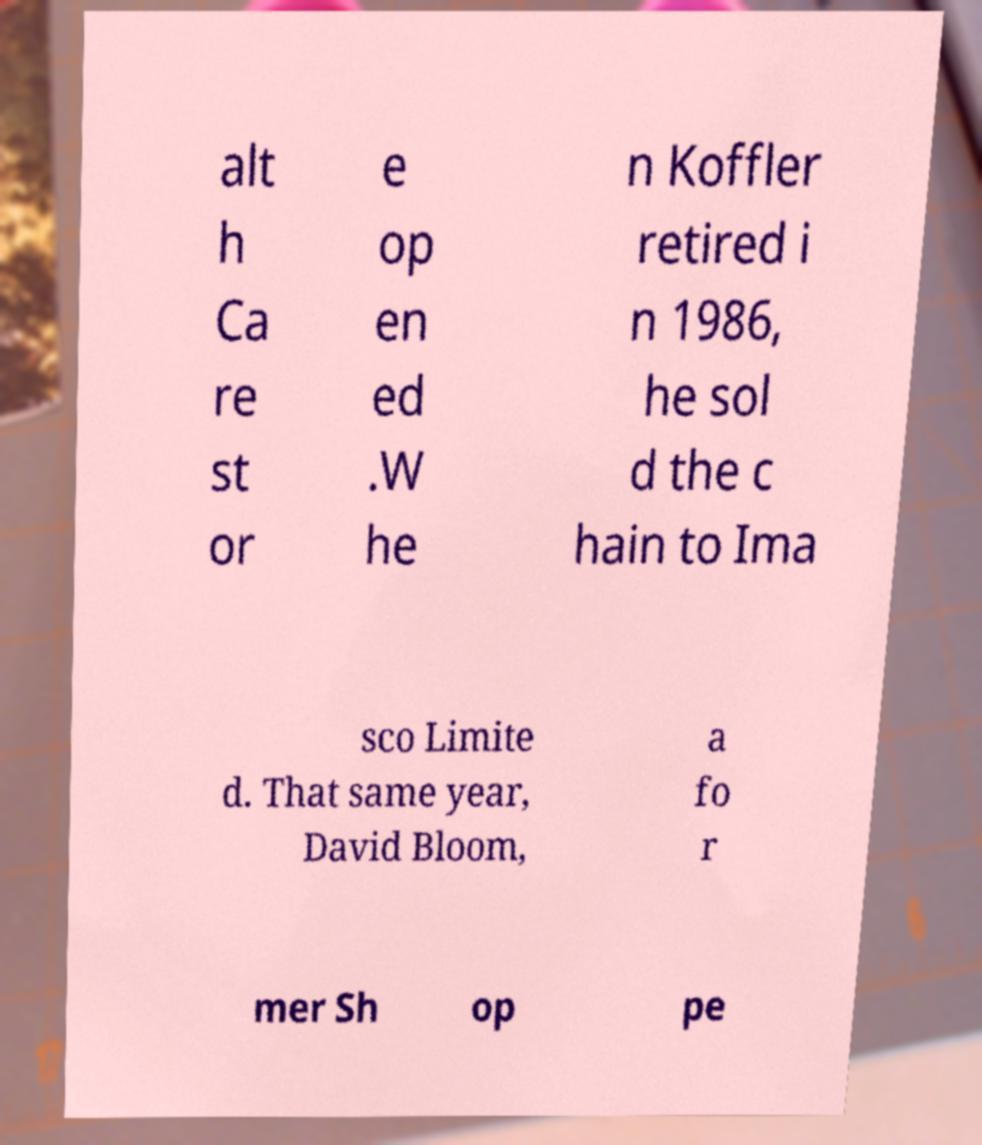There's text embedded in this image that I need extracted. Can you transcribe it verbatim? alt h Ca re st or e op en ed .W he n Koffler retired i n 1986, he sol d the c hain to Ima sco Limite d. That same year, David Bloom, a fo r mer Sh op pe 